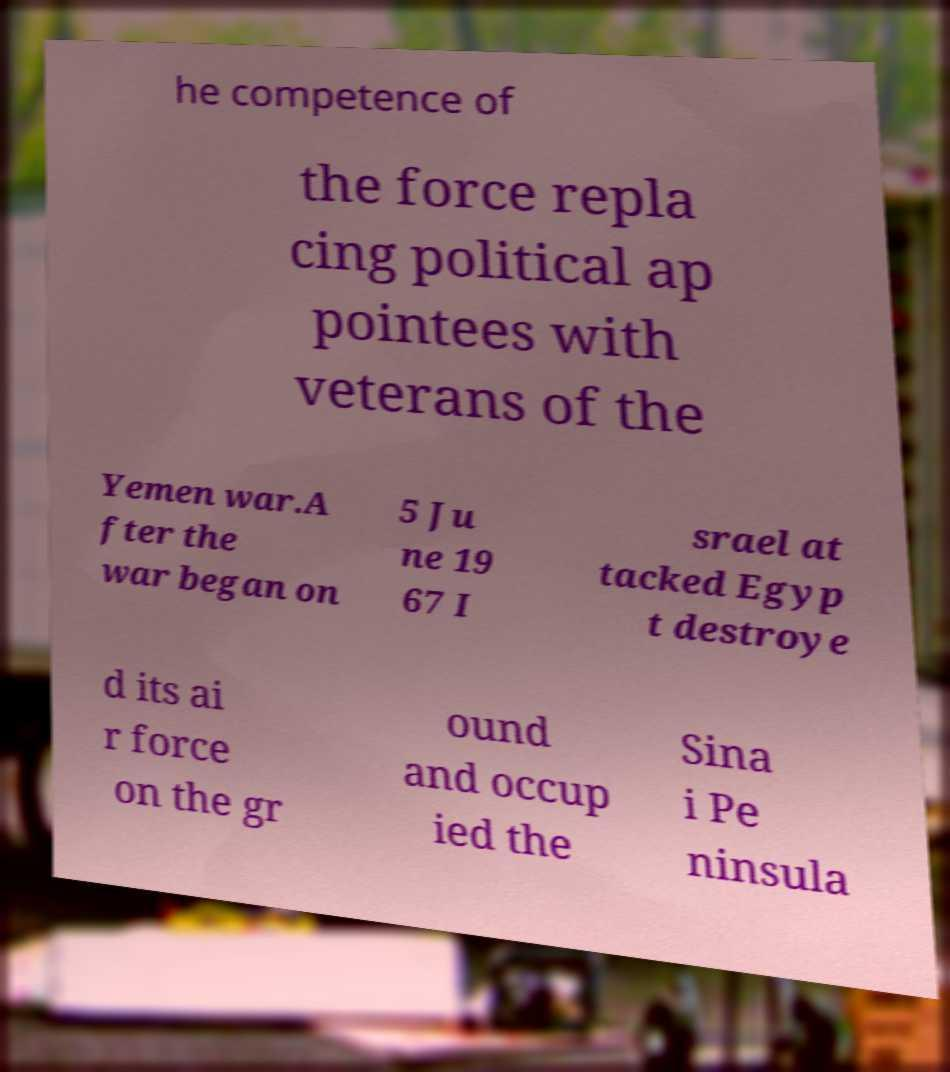Can you read and provide the text displayed in the image?This photo seems to have some interesting text. Can you extract and type it out for me? he competence of the force repla cing political ap pointees with veterans of the Yemen war.A fter the war began on 5 Ju ne 19 67 I srael at tacked Egyp t destroye d its ai r force on the gr ound and occup ied the Sina i Pe ninsula 